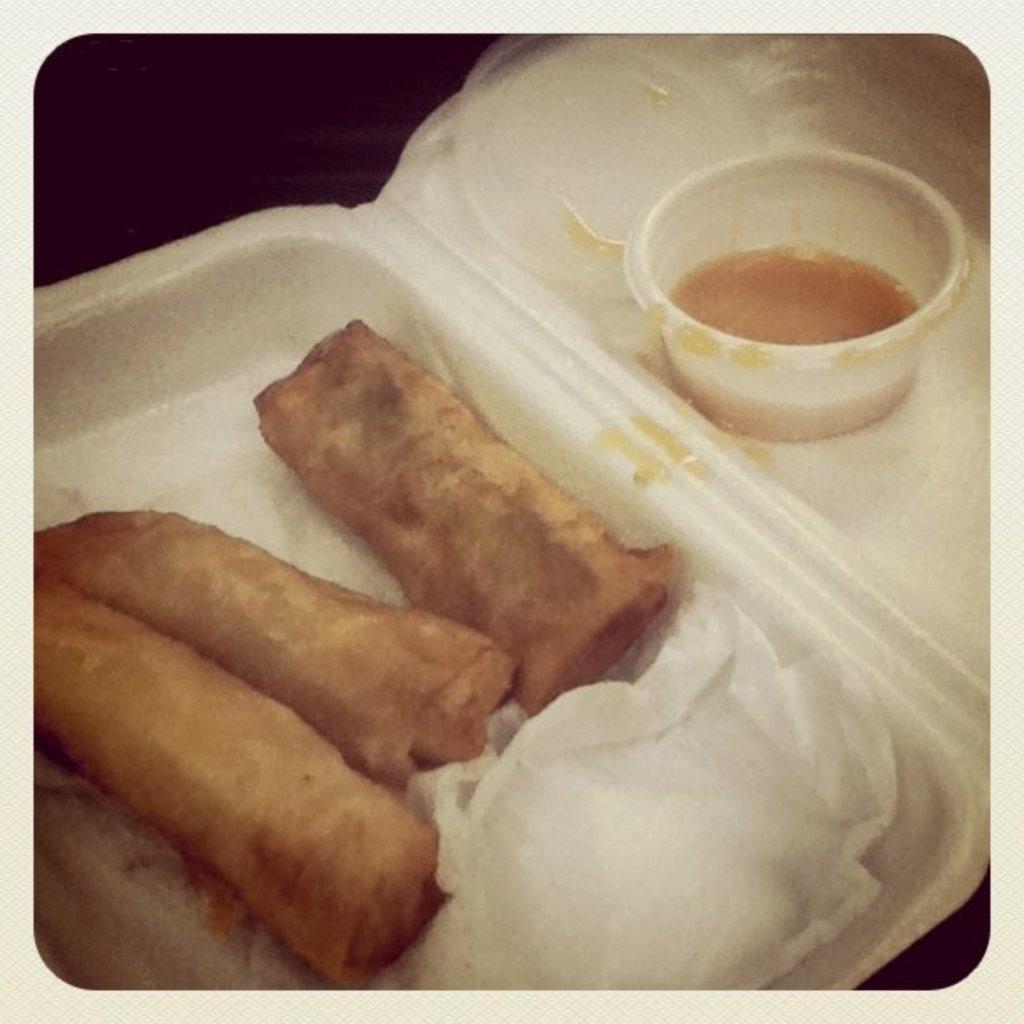In one or two sentences, can you explain what this image depicts? The picture of a food. These are rolls, for this roll there is a side dip in a cup. This food is presented in a box. Tissues are in white color. 